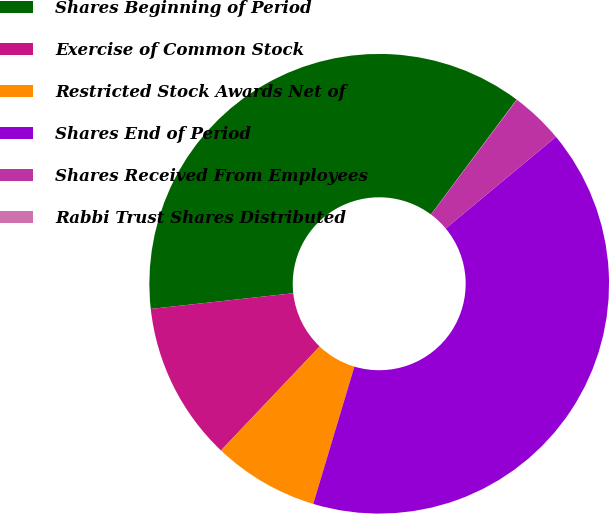Convert chart. <chart><loc_0><loc_0><loc_500><loc_500><pie_chart><fcel>Shares Beginning of Period<fcel>Exercise of Common Stock<fcel>Restricted Stock Awards Net of<fcel>Shares End of Period<fcel>Shares Received From Employees<fcel>Rabbi Trust Shares Distributed<nl><fcel>36.95%<fcel>11.17%<fcel>7.45%<fcel>40.67%<fcel>3.74%<fcel>0.02%<nl></chart> 